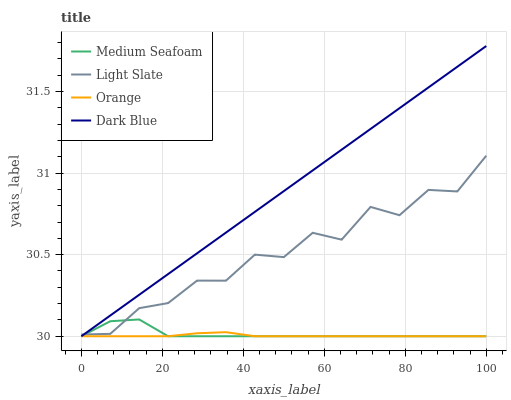Does Orange have the minimum area under the curve?
Answer yes or no. Yes. Does Dark Blue have the maximum area under the curve?
Answer yes or no. Yes. Does Medium Seafoam have the minimum area under the curve?
Answer yes or no. No. Does Medium Seafoam have the maximum area under the curve?
Answer yes or no. No. Is Dark Blue the smoothest?
Answer yes or no. Yes. Is Light Slate the roughest?
Answer yes or no. Yes. Is Orange the smoothest?
Answer yes or no. No. Is Orange the roughest?
Answer yes or no. No. Does Orange have the lowest value?
Answer yes or no. Yes. Does Dark Blue have the highest value?
Answer yes or no. Yes. Does Medium Seafoam have the highest value?
Answer yes or no. No. Is Orange less than Light Slate?
Answer yes or no. Yes. Is Light Slate greater than Orange?
Answer yes or no. Yes. Does Dark Blue intersect Orange?
Answer yes or no. Yes. Is Dark Blue less than Orange?
Answer yes or no. No. Is Dark Blue greater than Orange?
Answer yes or no. No. Does Orange intersect Light Slate?
Answer yes or no. No. 